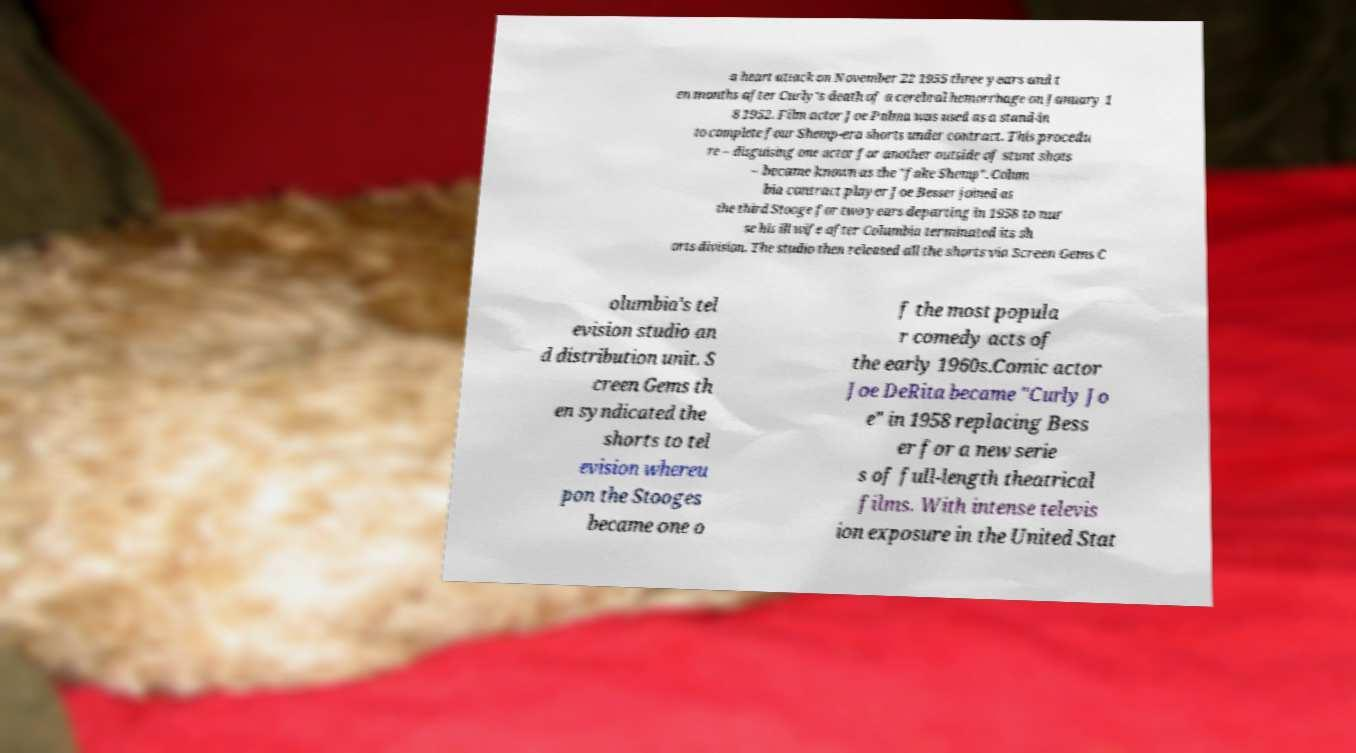What messages or text are displayed in this image? I need them in a readable, typed format. a heart attack on November 22 1955 three years and t en months after Curly's death of a cerebral hemorrhage on January 1 8 1952. Film actor Joe Palma was used as a stand-in to complete four Shemp-era shorts under contract. This procedu re – disguising one actor for another outside of stunt shots – became known as the "fake Shemp". Colum bia contract player Joe Besser joined as the third Stooge for two years departing in 1958 to nur se his ill wife after Columbia terminated its sh orts division. The studio then released all the shorts via Screen Gems C olumbia's tel evision studio an d distribution unit. S creen Gems th en syndicated the shorts to tel evision whereu pon the Stooges became one o f the most popula r comedy acts of the early 1960s.Comic actor Joe DeRita became "Curly Jo e" in 1958 replacing Bess er for a new serie s of full-length theatrical films. With intense televis ion exposure in the United Stat 